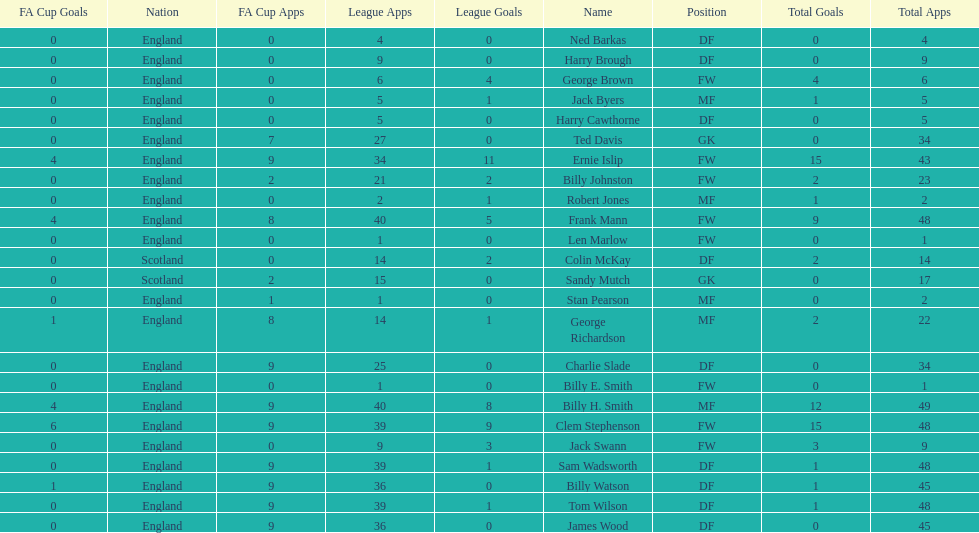How many players are fws? 8. 